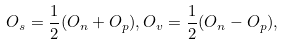Convert formula to latex. <formula><loc_0><loc_0><loc_500><loc_500>O _ { s } = \frac { 1 } { 2 } ( O _ { n } + O _ { p } ) , O _ { v } = \frac { 1 } { 2 } ( O _ { n } - O _ { p } ) ,</formula> 